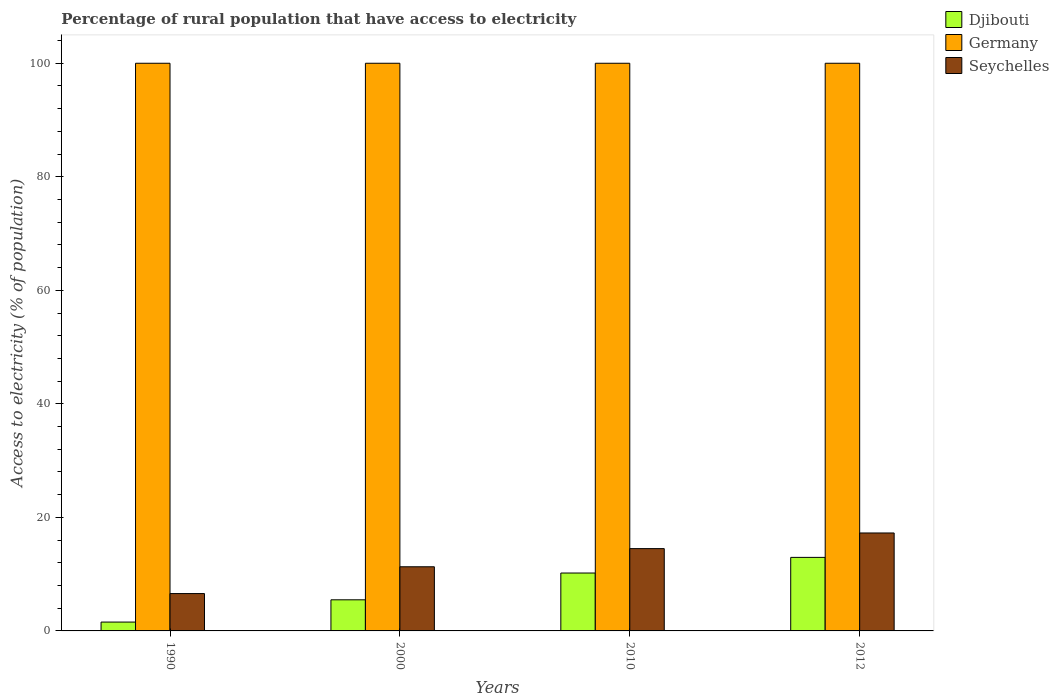How many different coloured bars are there?
Your response must be concise. 3. How many groups of bars are there?
Provide a succinct answer. 4. How many bars are there on the 2nd tick from the right?
Provide a succinct answer. 3. In how many cases, is the number of bars for a given year not equal to the number of legend labels?
Your response must be concise. 0. What is the percentage of rural population that have access to electricity in Seychelles in 2012?
Your response must be concise. 17.25. Across all years, what is the maximum percentage of rural population that have access to electricity in Djibouti?
Your answer should be compact. 12.95. Across all years, what is the minimum percentage of rural population that have access to electricity in Djibouti?
Your answer should be very brief. 1.56. In which year was the percentage of rural population that have access to electricity in Seychelles minimum?
Keep it short and to the point. 1990. What is the total percentage of rural population that have access to electricity in Germany in the graph?
Provide a succinct answer. 400. What is the difference between the percentage of rural population that have access to electricity in Seychelles in 1990 and that in 2000?
Your answer should be compact. -4.72. What is the difference between the percentage of rural population that have access to electricity in Germany in 2010 and the percentage of rural population that have access to electricity in Seychelles in 2012?
Make the answer very short. 82.75. What is the average percentage of rural population that have access to electricity in Djibouti per year?
Give a very brief answer. 7.55. In the year 2010, what is the difference between the percentage of rural population that have access to electricity in Djibouti and percentage of rural population that have access to electricity in Seychelles?
Your answer should be compact. -4.3. In how many years, is the percentage of rural population that have access to electricity in Seychelles greater than 16 %?
Offer a very short reply. 1. What is the ratio of the percentage of rural population that have access to electricity in Djibouti in 2010 to that in 2012?
Your answer should be very brief. 0.79. Is the percentage of rural population that have access to electricity in Seychelles in 1990 less than that in 2000?
Your answer should be compact. Yes. What is the difference between the highest and the lowest percentage of rural population that have access to electricity in Seychelles?
Your answer should be very brief. 10.68. What does the 1st bar from the left in 1990 represents?
Offer a terse response. Djibouti. Is it the case that in every year, the sum of the percentage of rural population that have access to electricity in Djibouti and percentage of rural population that have access to electricity in Seychelles is greater than the percentage of rural population that have access to electricity in Germany?
Your answer should be compact. No. How many bars are there?
Give a very brief answer. 12. Are all the bars in the graph horizontal?
Give a very brief answer. No. What is the difference between two consecutive major ticks on the Y-axis?
Your answer should be compact. 20. Are the values on the major ticks of Y-axis written in scientific E-notation?
Give a very brief answer. No. Does the graph contain any zero values?
Provide a short and direct response. No. Where does the legend appear in the graph?
Your answer should be very brief. Top right. How are the legend labels stacked?
Make the answer very short. Vertical. What is the title of the graph?
Keep it short and to the point. Percentage of rural population that have access to electricity. What is the label or title of the Y-axis?
Keep it short and to the point. Access to electricity (% of population). What is the Access to electricity (% of population) in Djibouti in 1990?
Your response must be concise. 1.56. What is the Access to electricity (% of population) of Seychelles in 1990?
Offer a terse response. 6.58. What is the Access to electricity (% of population) in Djibouti in 2000?
Make the answer very short. 5.48. What is the Access to electricity (% of population) in Seychelles in 2000?
Your answer should be very brief. 11.3. What is the Access to electricity (% of population) of Djibouti in 2012?
Make the answer very short. 12.95. What is the Access to electricity (% of population) in Seychelles in 2012?
Ensure brevity in your answer.  17.25. Across all years, what is the maximum Access to electricity (% of population) of Djibouti?
Your answer should be very brief. 12.95. Across all years, what is the maximum Access to electricity (% of population) in Germany?
Provide a succinct answer. 100. Across all years, what is the maximum Access to electricity (% of population) in Seychelles?
Give a very brief answer. 17.25. Across all years, what is the minimum Access to electricity (% of population) in Djibouti?
Your answer should be compact. 1.56. Across all years, what is the minimum Access to electricity (% of population) in Germany?
Ensure brevity in your answer.  100. Across all years, what is the minimum Access to electricity (% of population) of Seychelles?
Your answer should be very brief. 6.58. What is the total Access to electricity (% of population) of Djibouti in the graph?
Your response must be concise. 30.2. What is the total Access to electricity (% of population) in Germany in the graph?
Keep it short and to the point. 400. What is the total Access to electricity (% of population) of Seychelles in the graph?
Your answer should be compact. 49.64. What is the difference between the Access to electricity (% of population) in Djibouti in 1990 and that in 2000?
Provide a short and direct response. -3.92. What is the difference between the Access to electricity (% of population) in Germany in 1990 and that in 2000?
Offer a terse response. 0. What is the difference between the Access to electricity (% of population) of Seychelles in 1990 and that in 2000?
Your response must be concise. -4.72. What is the difference between the Access to electricity (% of population) of Djibouti in 1990 and that in 2010?
Your answer should be compact. -8.64. What is the difference between the Access to electricity (% of population) of Seychelles in 1990 and that in 2010?
Ensure brevity in your answer.  -7.92. What is the difference between the Access to electricity (% of population) of Djibouti in 1990 and that in 2012?
Provide a short and direct response. -11.39. What is the difference between the Access to electricity (% of population) in Seychelles in 1990 and that in 2012?
Provide a short and direct response. -10.68. What is the difference between the Access to electricity (% of population) of Djibouti in 2000 and that in 2010?
Your answer should be compact. -4.72. What is the difference between the Access to electricity (% of population) in Germany in 2000 and that in 2010?
Provide a short and direct response. 0. What is the difference between the Access to electricity (% of population) in Seychelles in 2000 and that in 2010?
Your answer should be very brief. -3.2. What is the difference between the Access to electricity (% of population) in Djibouti in 2000 and that in 2012?
Provide a short and direct response. -7.47. What is the difference between the Access to electricity (% of population) of Germany in 2000 and that in 2012?
Provide a short and direct response. 0. What is the difference between the Access to electricity (% of population) of Seychelles in 2000 and that in 2012?
Make the answer very short. -5.95. What is the difference between the Access to electricity (% of population) in Djibouti in 2010 and that in 2012?
Your answer should be very brief. -2.75. What is the difference between the Access to electricity (% of population) in Seychelles in 2010 and that in 2012?
Provide a succinct answer. -2.75. What is the difference between the Access to electricity (% of population) of Djibouti in 1990 and the Access to electricity (% of population) of Germany in 2000?
Give a very brief answer. -98.44. What is the difference between the Access to electricity (% of population) of Djibouti in 1990 and the Access to electricity (% of population) of Seychelles in 2000?
Your response must be concise. -9.74. What is the difference between the Access to electricity (% of population) in Germany in 1990 and the Access to electricity (% of population) in Seychelles in 2000?
Your answer should be very brief. 88.7. What is the difference between the Access to electricity (% of population) in Djibouti in 1990 and the Access to electricity (% of population) in Germany in 2010?
Give a very brief answer. -98.44. What is the difference between the Access to electricity (% of population) in Djibouti in 1990 and the Access to electricity (% of population) in Seychelles in 2010?
Provide a succinct answer. -12.94. What is the difference between the Access to electricity (% of population) in Germany in 1990 and the Access to electricity (% of population) in Seychelles in 2010?
Ensure brevity in your answer.  85.5. What is the difference between the Access to electricity (% of population) in Djibouti in 1990 and the Access to electricity (% of population) in Germany in 2012?
Your response must be concise. -98.44. What is the difference between the Access to electricity (% of population) in Djibouti in 1990 and the Access to electricity (% of population) in Seychelles in 2012?
Provide a short and direct response. -15.69. What is the difference between the Access to electricity (% of population) in Germany in 1990 and the Access to electricity (% of population) in Seychelles in 2012?
Provide a succinct answer. 82.75. What is the difference between the Access to electricity (% of population) of Djibouti in 2000 and the Access to electricity (% of population) of Germany in 2010?
Your answer should be very brief. -94.52. What is the difference between the Access to electricity (% of population) of Djibouti in 2000 and the Access to electricity (% of population) of Seychelles in 2010?
Your answer should be compact. -9.02. What is the difference between the Access to electricity (% of population) in Germany in 2000 and the Access to electricity (% of population) in Seychelles in 2010?
Your response must be concise. 85.5. What is the difference between the Access to electricity (% of population) of Djibouti in 2000 and the Access to electricity (% of population) of Germany in 2012?
Offer a very short reply. -94.52. What is the difference between the Access to electricity (% of population) in Djibouti in 2000 and the Access to electricity (% of population) in Seychelles in 2012?
Offer a very short reply. -11.77. What is the difference between the Access to electricity (% of population) in Germany in 2000 and the Access to electricity (% of population) in Seychelles in 2012?
Your answer should be very brief. 82.75. What is the difference between the Access to electricity (% of population) in Djibouti in 2010 and the Access to electricity (% of population) in Germany in 2012?
Your answer should be compact. -89.8. What is the difference between the Access to electricity (% of population) of Djibouti in 2010 and the Access to electricity (% of population) of Seychelles in 2012?
Keep it short and to the point. -7.05. What is the difference between the Access to electricity (% of population) of Germany in 2010 and the Access to electricity (% of population) of Seychelles in 2012?
Offer a very short reply. 82.75. What is the average Access to electricity (% of population) of Djibouti per year?
Your answer should be very brief. 7.55. What is the average Access to electricity (% of population) of Germany per year?
Offer a terse response. 100. What is the average Access to electricity (% of population) in Seychelles per year?
Your answer should be very brief. 12.41. In the year 1990, what is the difference between the Access to electricity (% of population) in Djibouti and Access to electricity (% of population) in Germany?
Offer a very short reply. -98.44. In the year 1990, what is the difference between the Access to electricity (% of population) of Djibouti and Access to electricity (% of population) of Seychelles?
Your response must be concise. -5.02. In the year 1990, what is the difference between the Access to electricity (% of population) in Germany and Access to electricity (% of population) in Seychelles?
Offer a very short reply. 93.42. In the year 2000, what is the difference between the Access to electricity (% of population) in Djibouti and Access to electricity (% of population) in Germany?
Your response must be concise. -94.52. In the year 2000, what is the difference between the Access to electricity (% of population) of Djibouti and Access to electricity (% of population) of Seychelles?
Offer a very short reply. -5.82. In the year 2000, what is the difference between the Access to electricity (% of population) of Germany and Access to electricity (% of population) of Seychelles?
Your answer should be very brief. 88.7. In the year 2010, what is the difference between the Access to electricity (% of population) in Djibouti and Access to electricity (% of population) in Germany?
Ensure brevity in your answer.  -89.8. In the year 2010, what is the difference between the Access to electricity (% of population) of Djibouti and Access to electricity (% of population) of Seychelles?
Offer a terse response. -4.3. In the year 2010, what is the difference between the Access to electricity (% of population) of Germany and Access to electricity (% of population) of Seychelles?
Provide a succinct answer. 85.5. In the year 2012, what is the difference between the Access to electricity (% of population) of Djibouti and Access to electricity (% of population) of Germany?
Give a very brief answer. -87.05. In the year 2012, what is the difference between the Access to electricity (% of population) in Djibouti and Access to electricity (% of population) in Seychelles?
Your answer should be very brief. -4.3. In the year 2012, what is the difference between the Access to electricity (% of population) in Germany and Access to electricity (% of population) in Seychelles?
Keep it short and to the point. 82.75. What is the ratio of the Access to electricity (% of population) of Djibouti in 1990 to that in 2000?
Offer a very short reply. 0.28. What is the ratio of the Access to electricity (% of population) of Germany in 1990 to that in 2000?
Keep it short and to the point. 1. What is the ratio of the Access to electricity (% of population) in Seychelles in 1990 to that in 2000?
Give a very brief answer. 0.58. What is the ratio of the Access to electricity (% of population) in Djibouti in 1990 to that in 2010?
Ensure brevity in your answer.  0.15. What is the ratio of the Access to electricity (% of population) in Germany in 1990 to that in 2010?
Offer a terse response. 1. What is the ratio of the Access to electricity (% of population) of Seychelles in 1990 to that in 2010?
Ensure brevity in your answer.  0.45. What is the ratio of the Access to electricity (% of population) in Djibouti in 1990 to that in 2012?
Ensure brevity in your answer.  0.12. What is the ratio of the Access to electricity (% of population) of Germany in 1990 to that in 2012?
Offer a very short reply. 1. What is the ratio of the Access to electricity (% of population) in Seychelles in 1990 to that in 2012?
Your answer should be compact. 0.38. What is the ratio of the Access to electricity (% of population) in Djibouti in 2000 to that in 2010?
Provide a short and direct response. 0.54. What is the ratio of the Access to electricity (% of population) of Seychelles in 2000 to that in 2010?
Your answer should be very brief. 0.78. What is the ratio of the Access to electricity (% of population) in Djibouti in 2000 to that in 2012?
Your response must be concise. 0.42. What is the ratio of the Access to electricity (% of population) in Seychelles in 2000 to that in 2012?
Keep it short and to the point. 0.66. What is the ratio of the Access to electricity (% of population) in Djibouti in 2010 to that in 2012?
Offer a very short reply. 0.79. What is the ratio of the Access to electricity (% of population) of Germany in 2010 to that in 2012?
Your response must be concise. 1. What is the ratio of the Access to electricity (% of population) of Seychelles in 2010 to that in 2012?
Offer a terse response. 0.84. What is the difference between the highest and the second highest Access to electricity (% of population) in Djibouti?
Offer a very short reply. 2.75. What is the difference between the highest and the second highest Access to electricity (% of population) in Seychelles?
Provide a short and direct response. 2.75. What is the difference between the highest and the lowest Access to electricity (% of population) in Djibouti?
Make the answer very short. 11.39. What is the difference between the highest and the lowest Access to electricity (% of population) in Germany?
Offer a terse response. 0. What is the difference between the highest and the lowest Access to electricity (% of population) in Seychelles?
Make the answer very short. 10.68. 